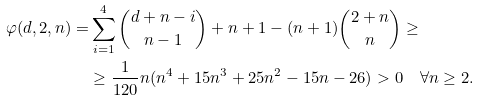<formula> <loc_0><loc_0><loc_500><loc_500>\varphi ( d , 2 , n ) = & \sum _ { i = 1 } ^ { 4 } \binom { d + n - i } { n - 1 } + n + 1 - ( n + 1 ) \binom { 2 + n } { n } \geq \\ & \geq \frac { 1 } { 1 2 0 } n ( n ^ { 4 } + 1 5 n ^ { 3 } + 2 5 n ^ { 2 } - 1 5 n - 2 6 ) > 0 \quad \forall n \geq 2 .</formula> 